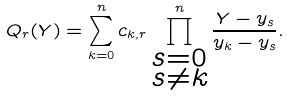Convert formula to latex. <formula><loc_0><loc_0><loc_500><loc_500>Q _ { r } ( Y ) = \sum _ { k = 0 } ^ { n } c _ { k , r } \prod _ { \substack { s = 0 \\ s \neq k } } ^ { n } \frac { Y - y _ { s } } { y _ { k } - y _ { s } } .</formula> 